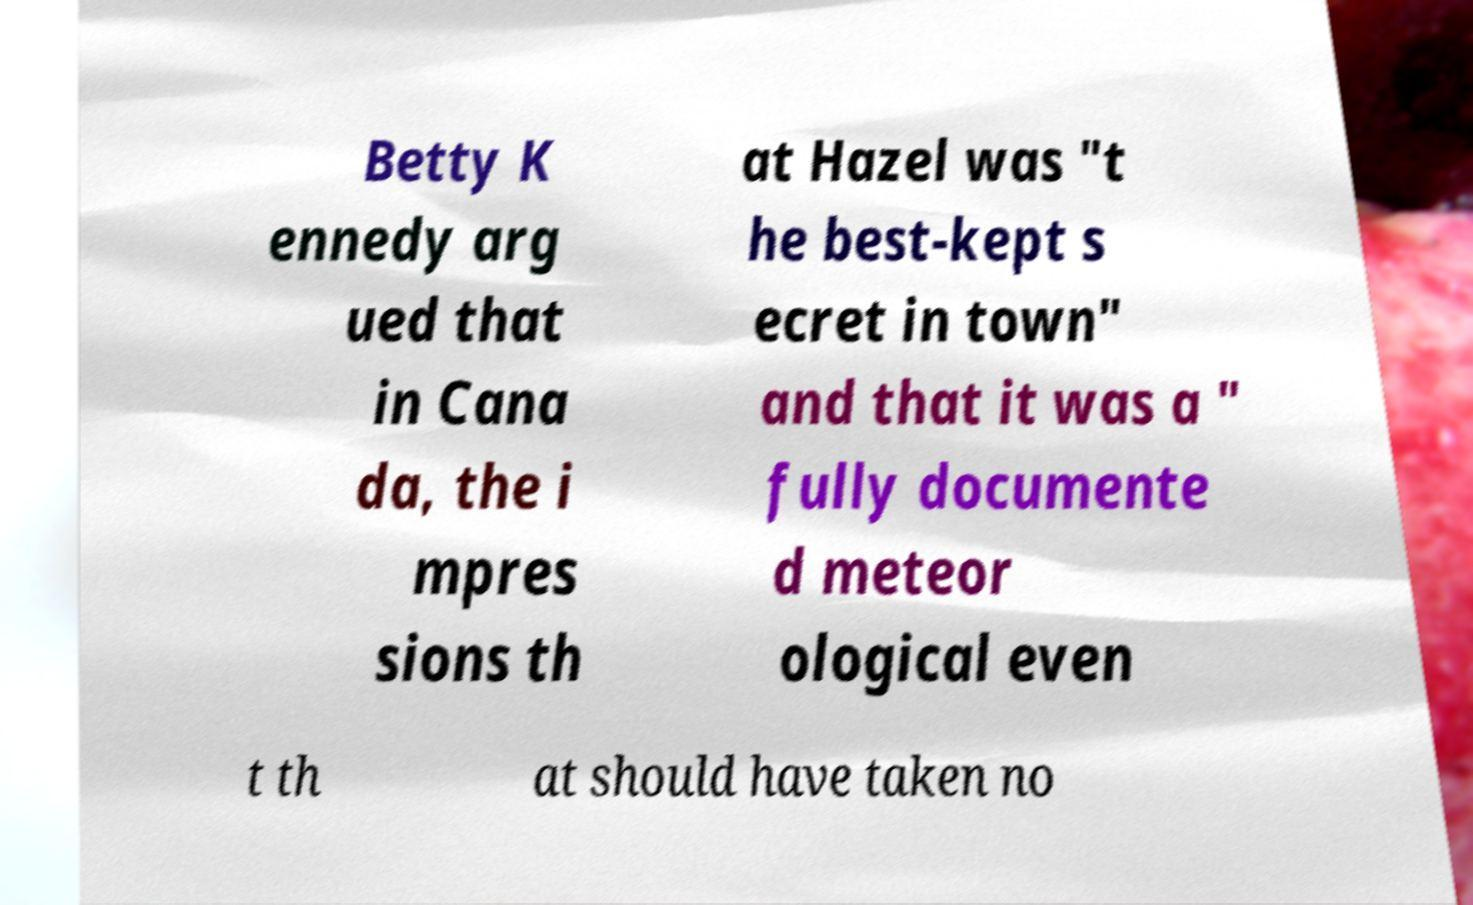For documentation purposes, I need the text within this image transcribed. Could you provide that? Betty K ennedy arg ued that in Cana da, the i mpres sions th at Hazel was "t he best-kept s ecret in town" and that it was a " fully documente d meteor ological even t th at should have taken no 